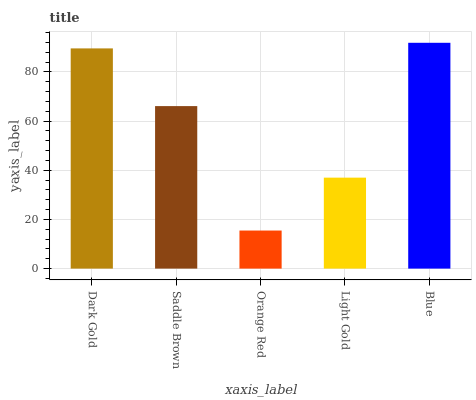Is Orange Red the minimum?
Answer yes or no. Yes. Is Blue the maximum?
Answer yes or no. Yes. Is Saddle Brown the minimum?
Answer yes or no. No. Is Saddle Brown the maximum?
Answer yes or no. No. Is Dark Gold greater than Saddle Brown?
Answer yes or no. Yes. Is Saddle Brown less than Dark Gold?
Answer yes or no. Yes. Is Saddle Brown greater than Dark Gold?
Answer yes or no. No. Is Dark Gold less than Saddle Brown?
Answer yes or no. No. Is Saddle Brown the high median?
Answer yes or no. Yes. Is Saddle Brown the low median?
Answer yes or no. Yes. Is Light Gold the high median?
Answer yes or no. No. Is Orange Red the low median?
Answer yes or no. No. 